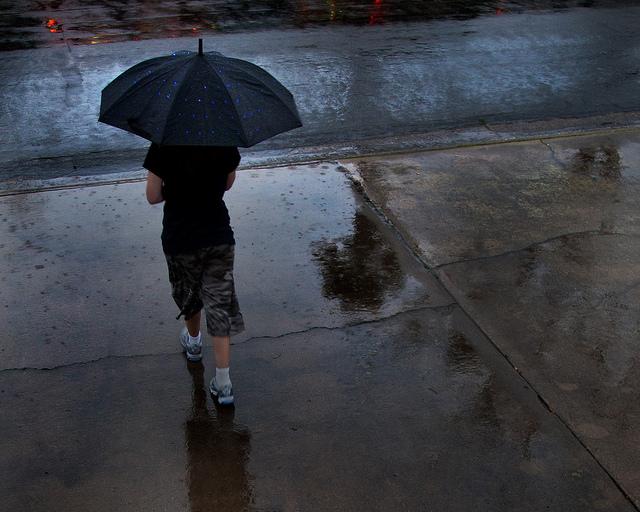What kind of shorts is she wearing?
Write a very short answer. Capris. Is she wearing shoes?
Answer briefly. Yes. Is it a sunny day?
Concise answer only. No. What does the umbrella have on top of it?
Concise answer only. Rain. Is it raining?
Keep it brief. Yes. Who is holding an umbrella?
Give a very brief answer. Woman. 